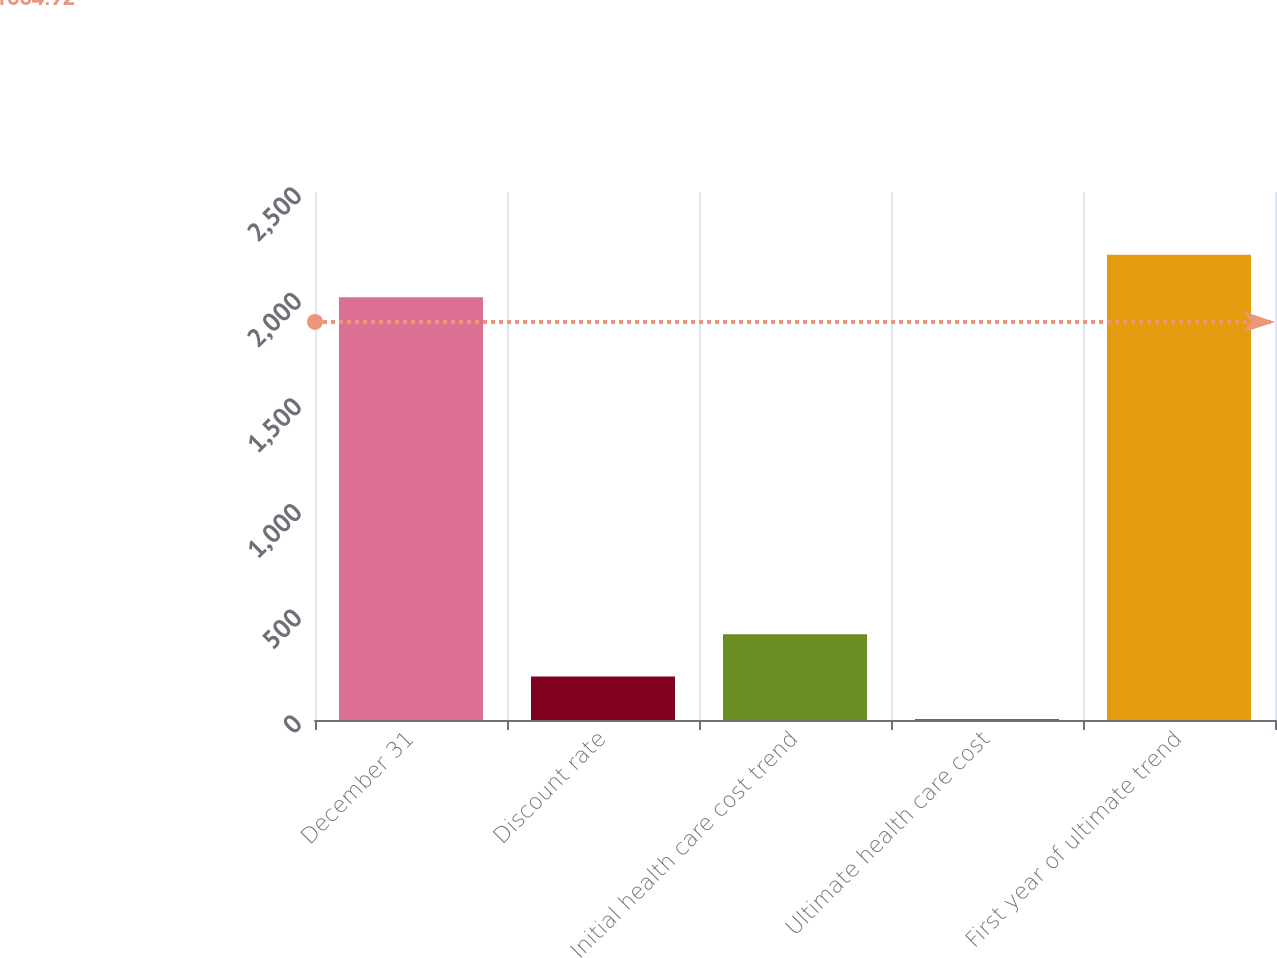<chart> <loc_0><loc_0><loc_500><loc_500><bar_chart><fcel>December 31<fcel>Discount rate<fcel>Initial health care cost trend<fcel>Ultimate health care cost<fcel>First year of ultimate trend<nl><fcel>2002<fcel>205.7<fcel>406.4<fcel>5<fcel>2202.7<nl></chart> 